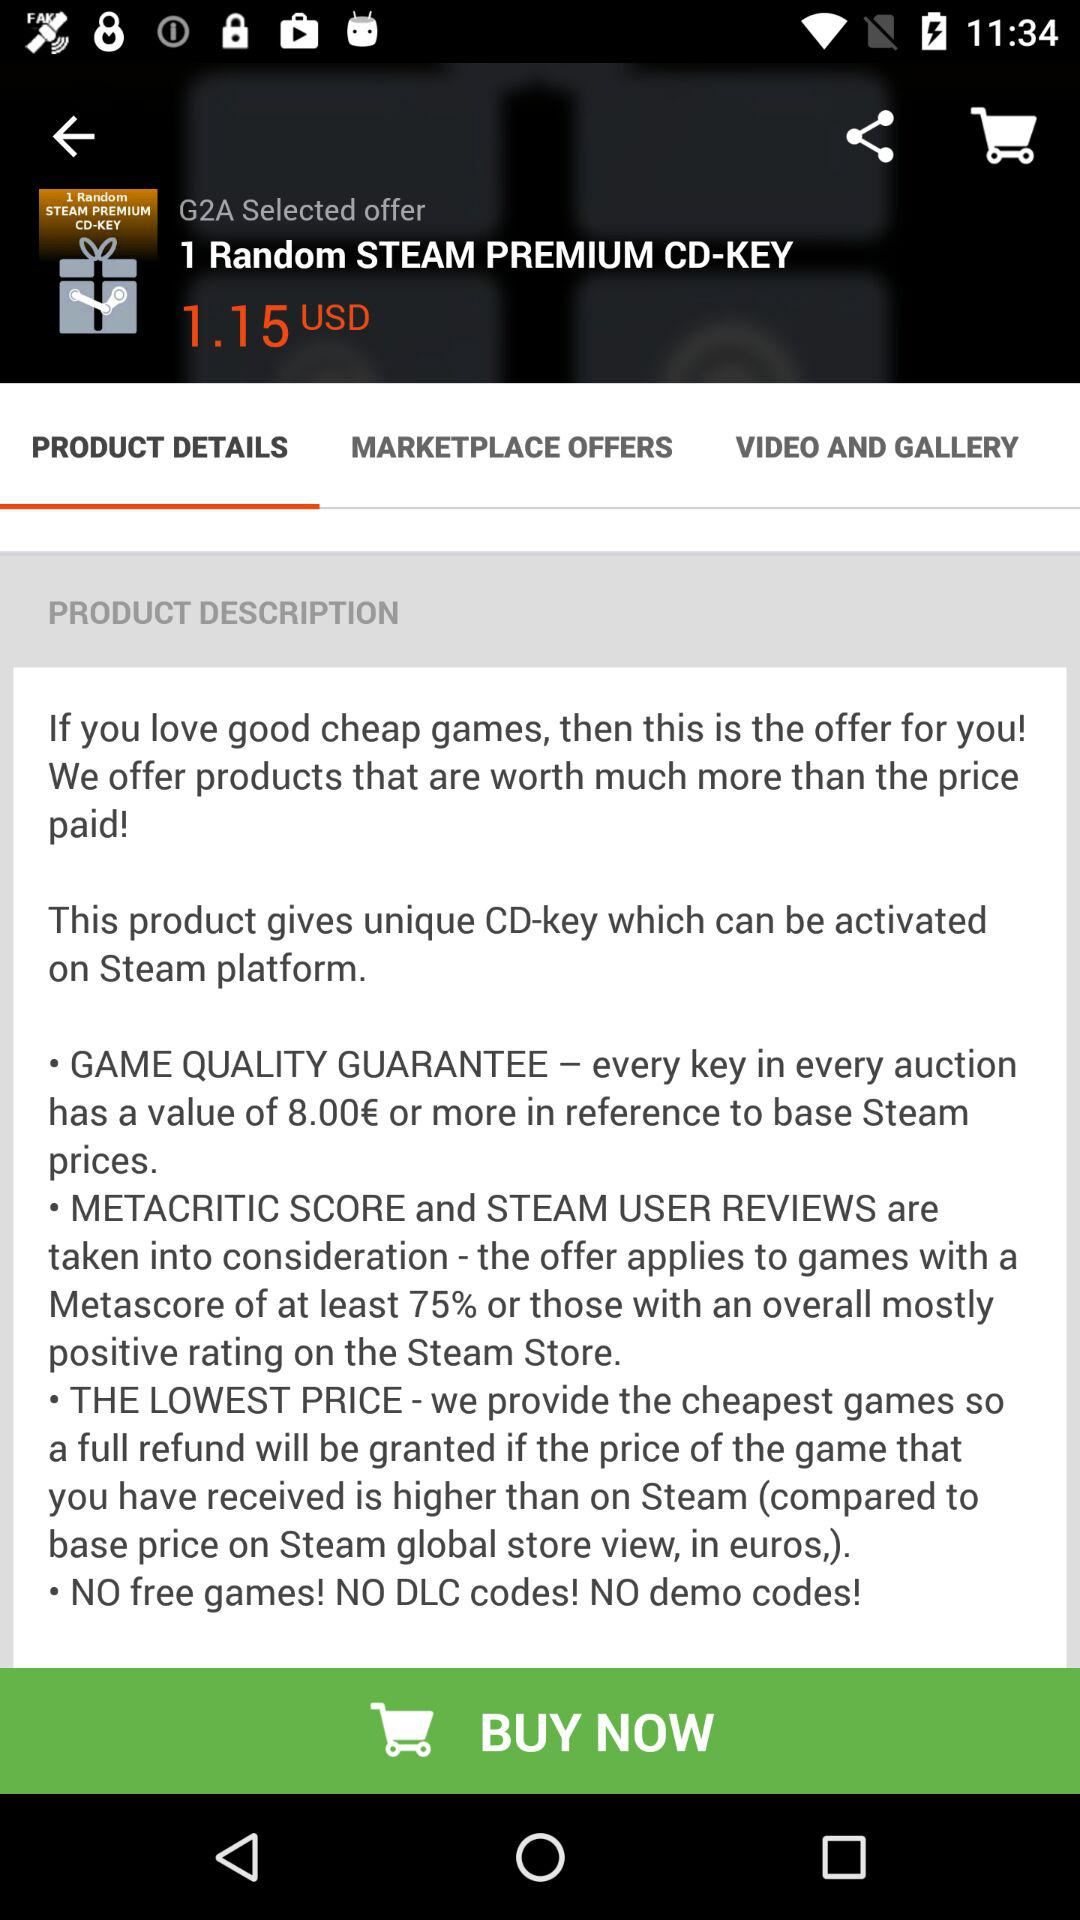What's the Offer? The offer is "1 Random STEAM PREMIUM CD-KEY". 